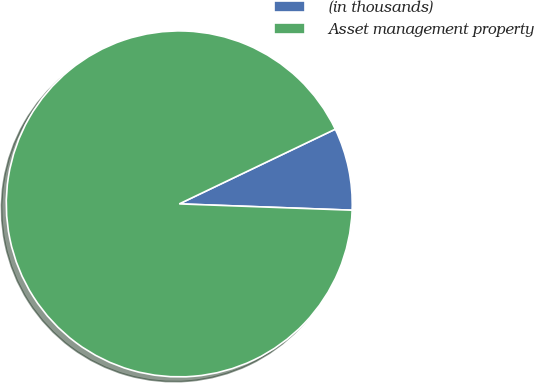Convert chart to OTSL. <chart><loc_0><loc_0><loc_500><loc_500><pie_chart><fcel>(in thousands)<fcel>Asset management property<nl><fcel>7.69%<fcel>92.31%<nl></chart> 